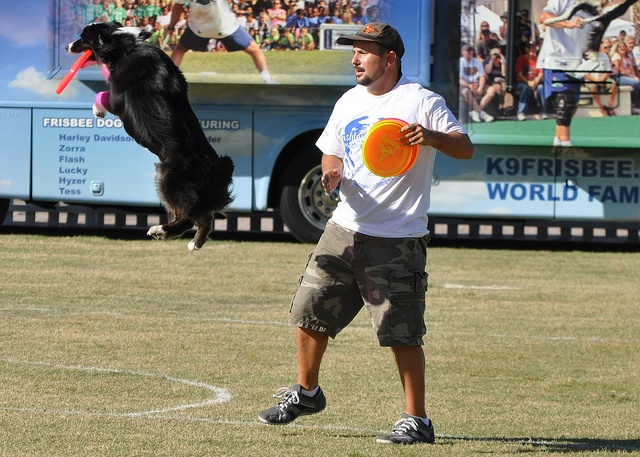Describe the objects in this image and their specific colors. I can see truck in gray, black, lightblue, and darkgray tones, bus in gray, black, lightblue, and darkgray tones, people in gray, black, white, maroon, and darkgray tones, dog in gray, black, maroon, and darkgray tones, and people in gray, black, darkgray, and lightgray tones in this image. 